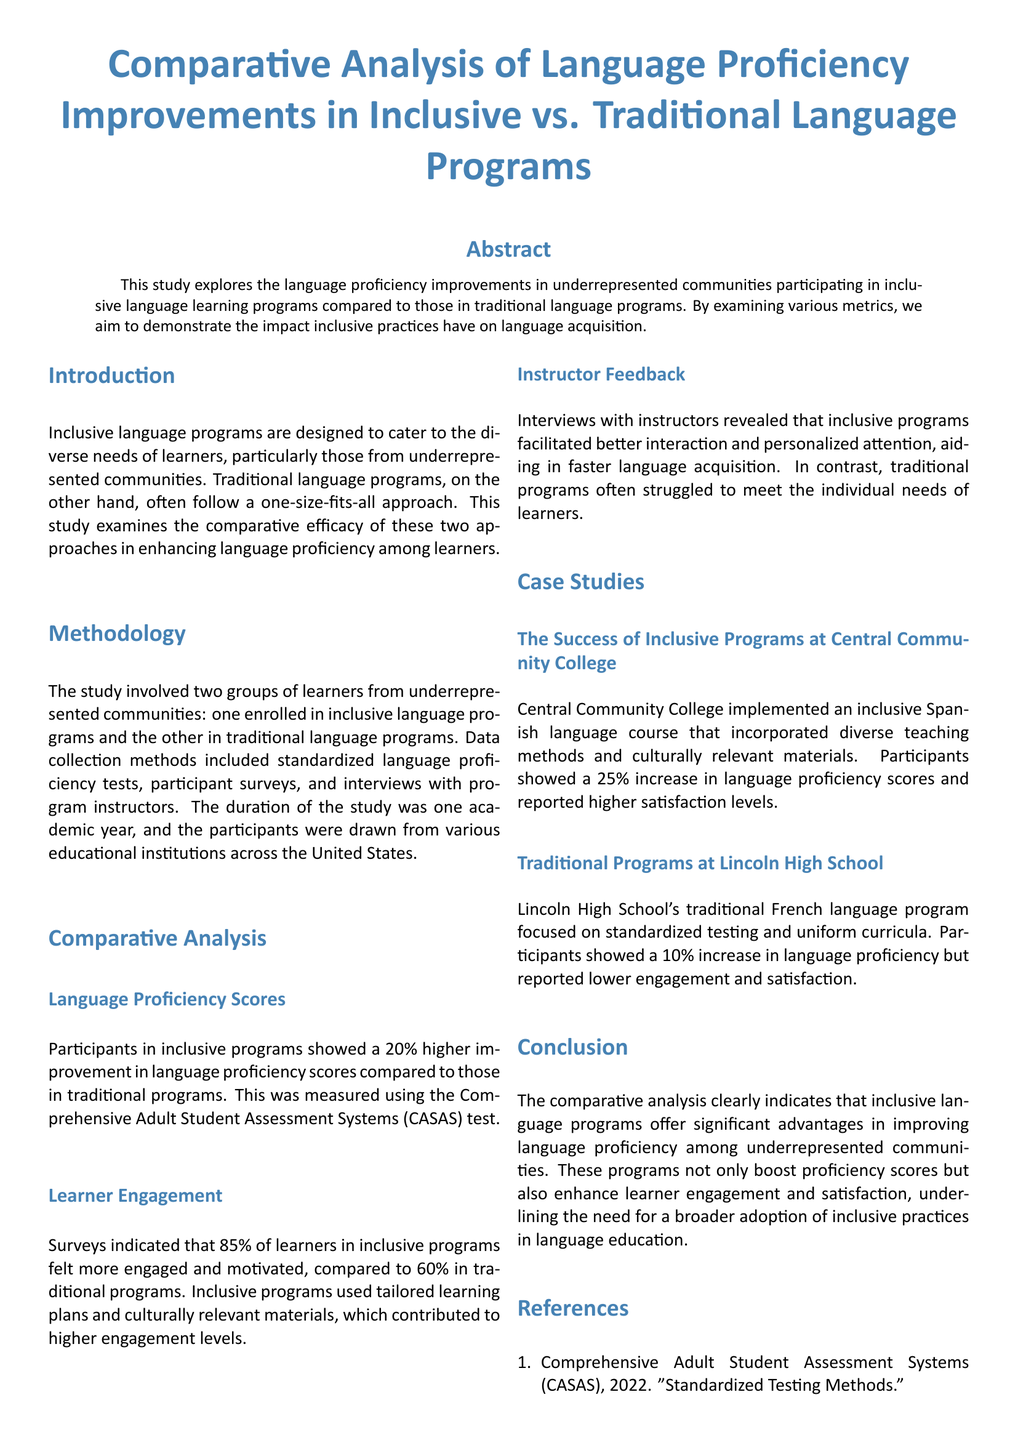What was the percentage improvement in language proficiency scores for inclusive programs? The inclusive programs showed a 20% higher improvement in language proficiency scores compared to traditional programs.
Answer: 20% What assessment method was used to measure language proficiency? The language proficiency was measured using the Comprehensive Adult Student Assessment Systems (CASAS) test.
Answer: CASAS What percentage of learners in inclusive programs felt more engaged? According to the surveys, 85% of learners in inclusive programs felt more engaged and motivated.
Answer: 85% How much did participants at Central Community College increase their language proficiency scores? Participants at Central Community College showed a 25% increase in language proficiency scores.
Answer: 25% What was a key factor contributing to learner engagement in inclusive programs? Tailored learning plans and culturally relevant materials contributed to higher engagement levels.
Answer: Tailored learning plans and culturally relevant materials What percentage of participants in traditional programs reported a lower engagement? In traditional programs, 60% of participants reported feeling engaged, indicating a lower level of engagement.
Answer: 60% What type of feedback did instructors give regarding inclusive programs? Instructors revealed that inclusive programs facilitated better interaction and personalized attention.
Answer: Better interaction and personalized attention Which program had a focus on standardized testing and uniform curricula? The traditional language program at Lincoln High School focused on standardized testing and uniform curricula.
Answer: Lincoln High School What was the duration of the study conducted? The study was conducted over one academic year.
Answer: One academic year 